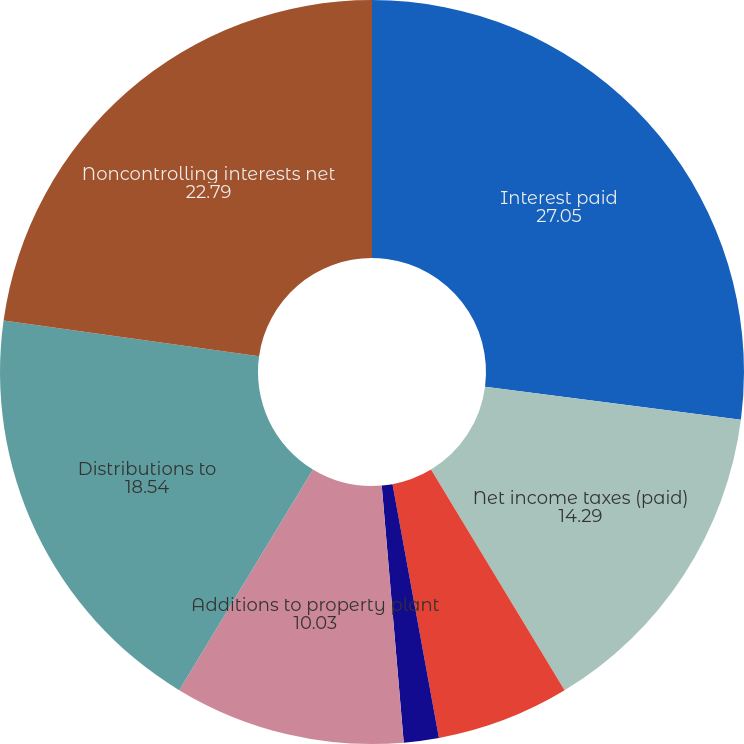Convert chart. <chart><loc_0><loc_0><loc_500><loc_500><pie_chart><fcel>Interest paid<fcel>Net income taxes (paid)<fcel>Capital expenditures incurred<fcel>Increase (decrease) in related<fcel>Additions to property plant<fcel>Distributions to<fcel>Noncontrolling interests net<nl><fcel>27.05%<fcel>14.29%<fcel>5.78%<fcel>1.52%<fcel>10.03%<fcel>18.54%<fcel>22.79%<nl></chart> 